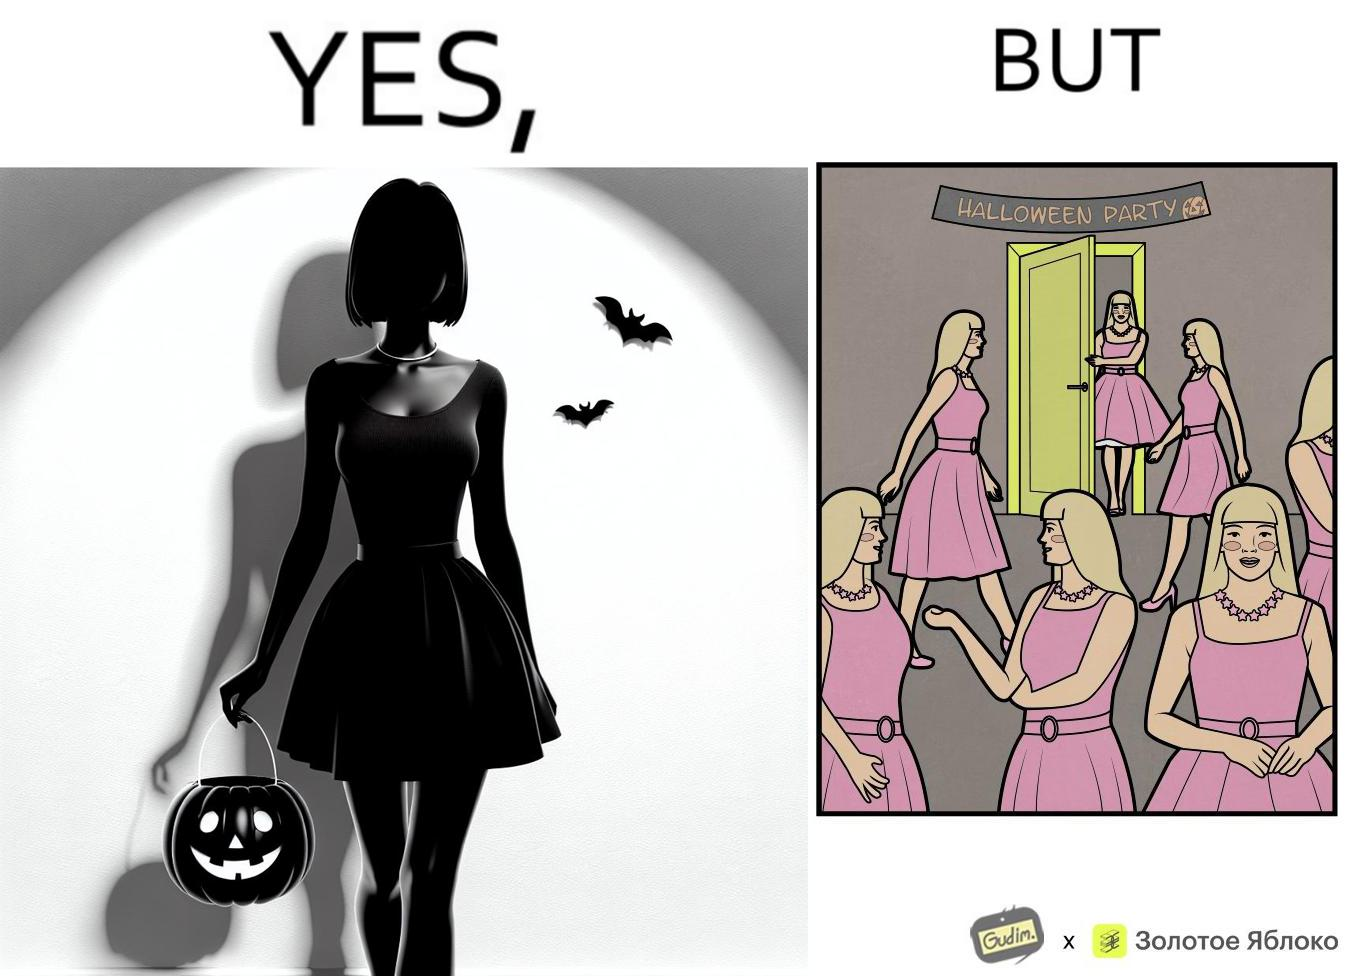Explain the humor or irony in this image. The image is funny, as the person entering the Halloween Party has a costume that is identical to many other people in the party. 